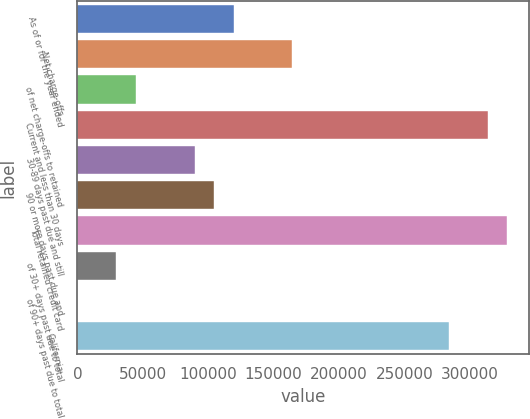<chart> <loc_0><loc_0><loc_500><loc_500><bar_chart><fcel>As of or for the year ended<fcel>Net charge-offs<fcel>of net charge-offs to retained<fcel>Current and less than 30 days<fcel>30-89 days past due and still<fcel>90 or more days past due and<fcel>Total retained credit card<fcel>of 30+ days past due to total<fcel>of 90+ days past due to total<fcel>California<nl><fcel>119510<fcel>164326<fcel>44816.8<fcel>313712<fcel>89632.6<fcel>104571<fcel>328650<fcel>29878.1<fcel>0.92<fcel>283835<nl></chart> 